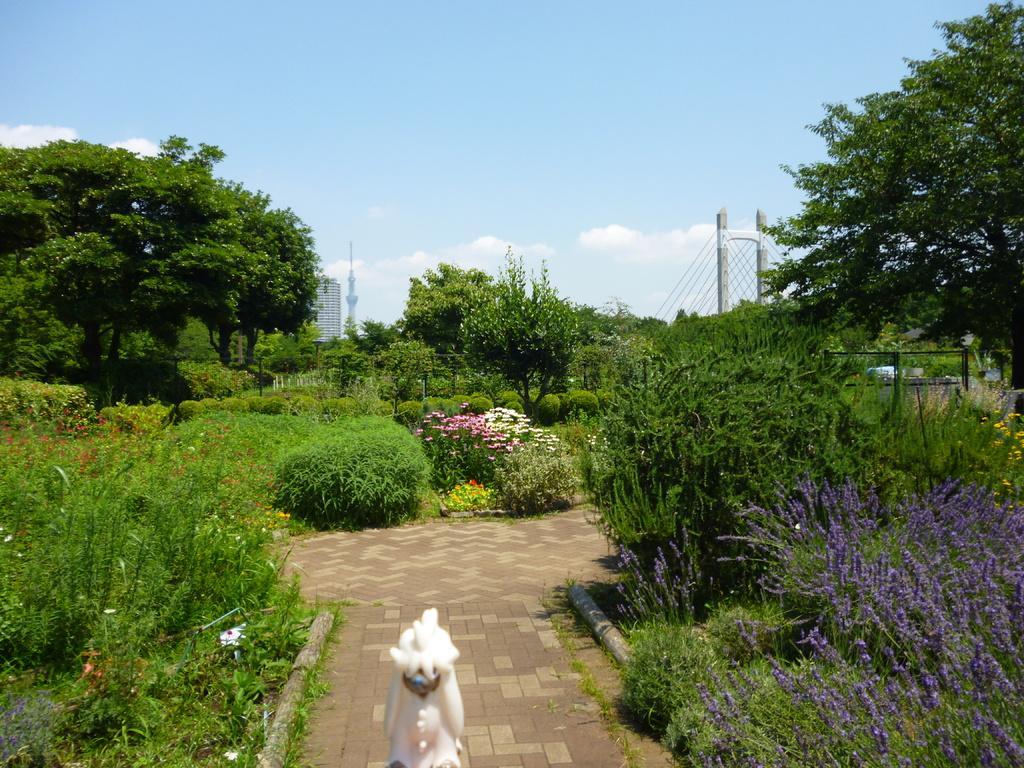Could you give a brief overview of what you see in this image? In this image we can see something which is white color. Here we can see the path, On the either side we can see plants, shrubs, fence, buildings, bridge and the sky with clouds in the background. 